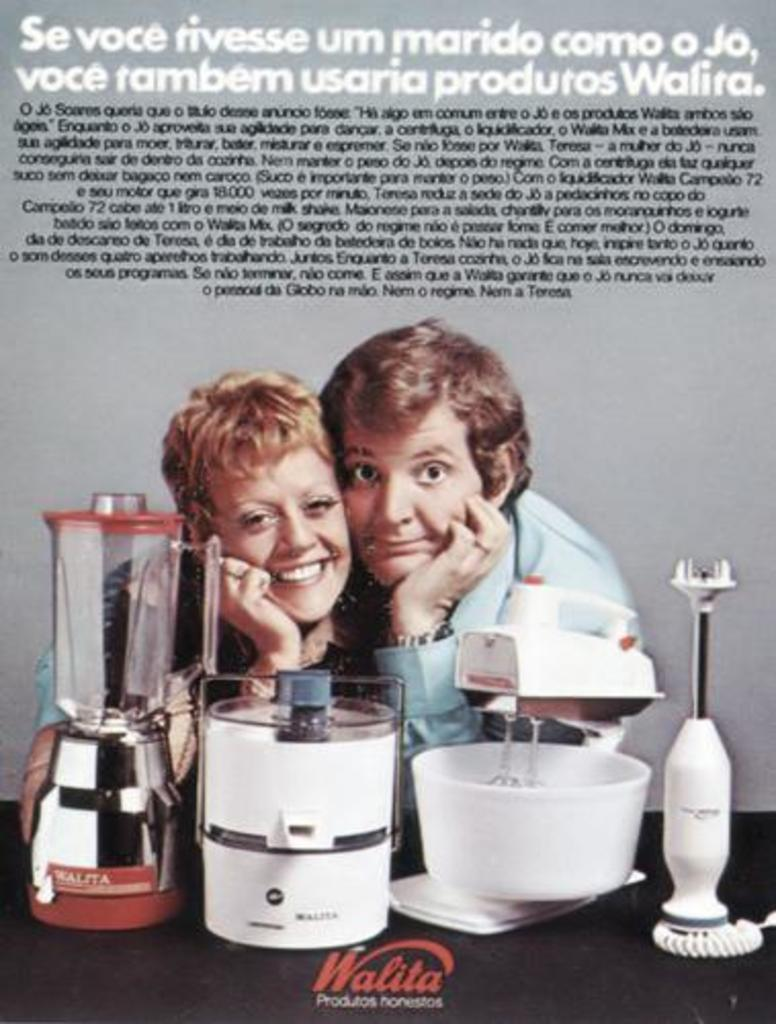<image>
Describe the image concisely. A Walita ad features two people and some kitchen appliances. 